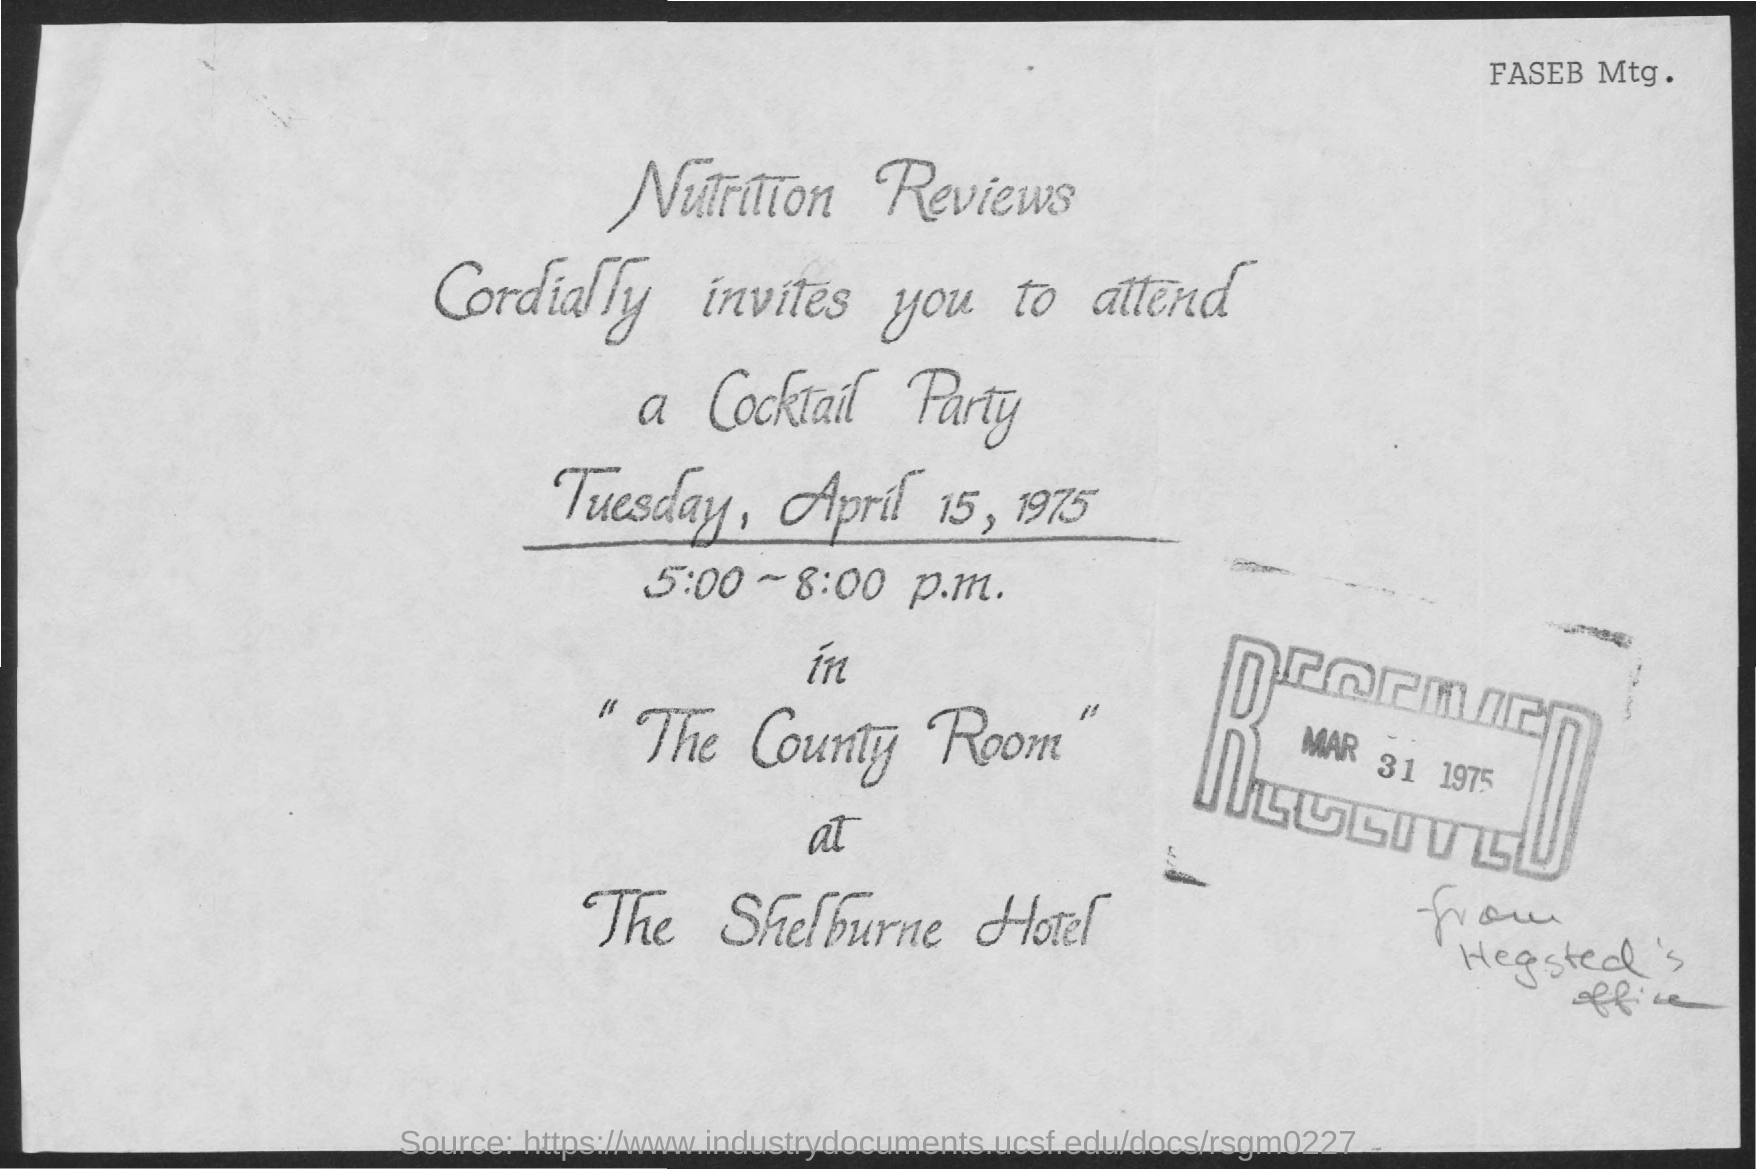Indicate a few pertinent items in this graphic. The party named "Cocktail Party" was mentioned. The name of the hotel mentioned is The Shelburne Hotel. What is the name of the room mentioned, which is commonly referred to as the county room? The date mentioned is "MAR 31 1975. The time mentioned in the given form is between 5:00 and 8:00 p.m. 